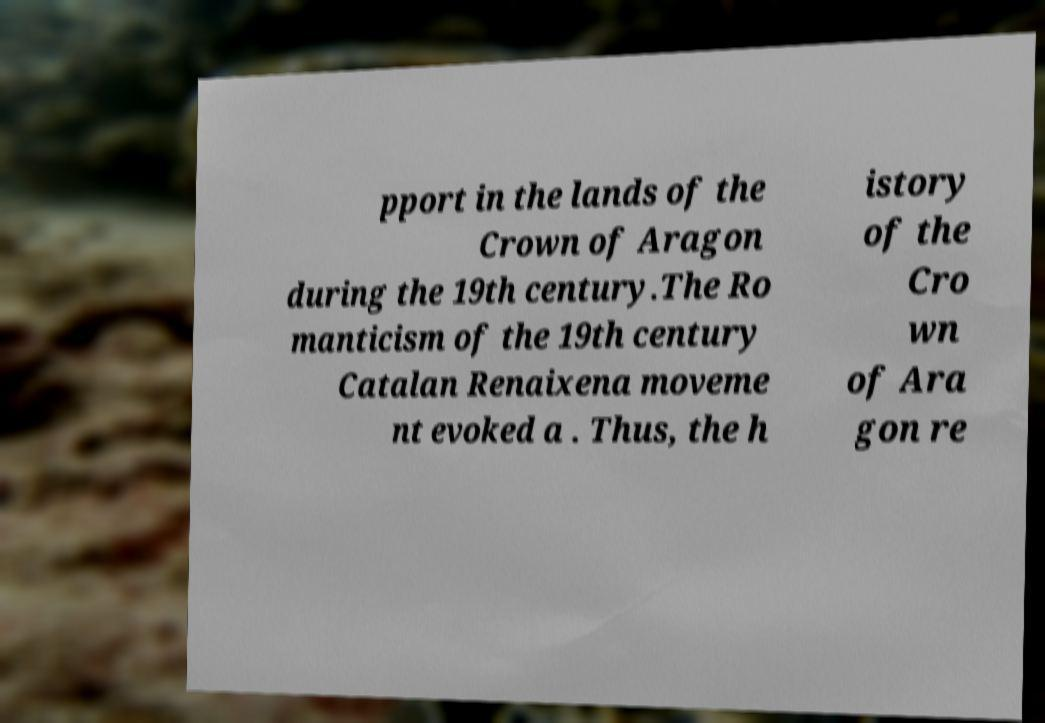There's text embedded in this image that I need extracted. Can you transcribe it verbatim? pport in the lands of the Crown of Aragon during the 19th century.The Ro manticism of the 19th century Catalan Renaixena moveme nt evoked a . Thus, the h istory of the Cro wn of Ara gon re 